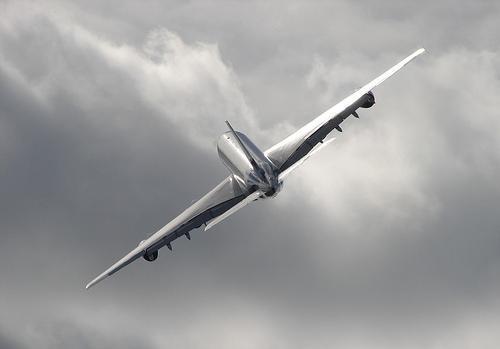How many planes are in the photo?
Give a very brief answer. 1. How many wings are on the plane?
Give a very brief answer. 2. 